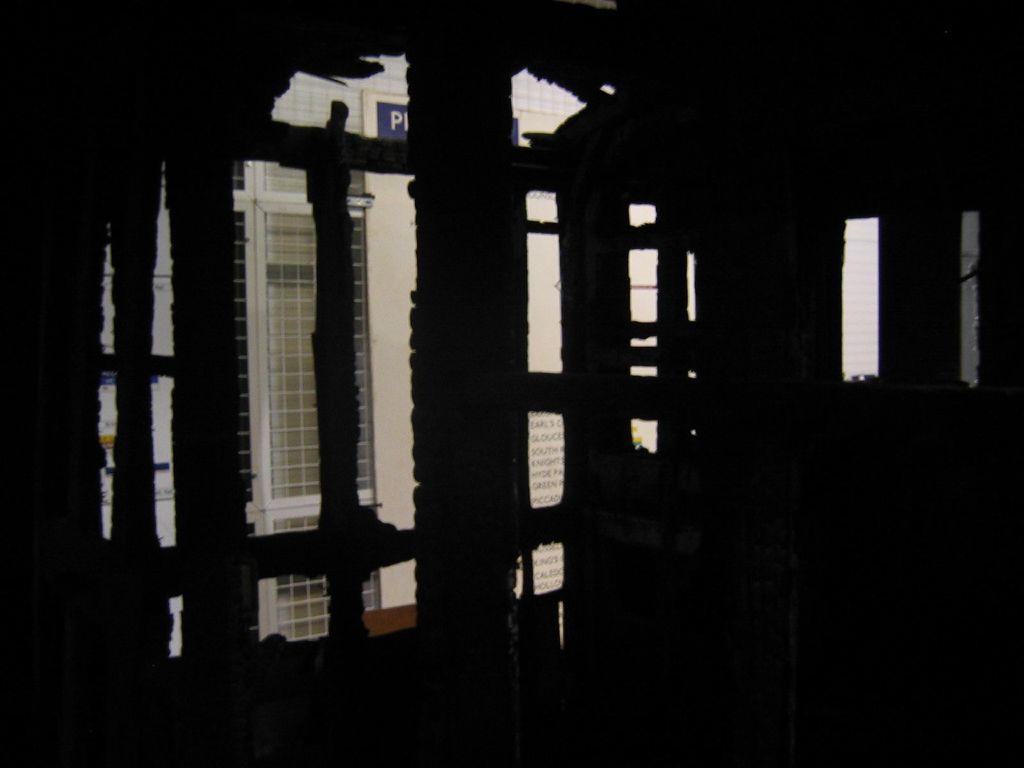Describe this image in one or two sentences. This image is taken from inside a building through the window, outside building is visible. 